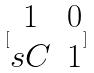Convert formula to latex. <formula><loc_0><loc_0><loc_500><loc_500>[ \begin{matrix} 1 & 0 \\ s C & 1 \end{matrix} ]</formula> 